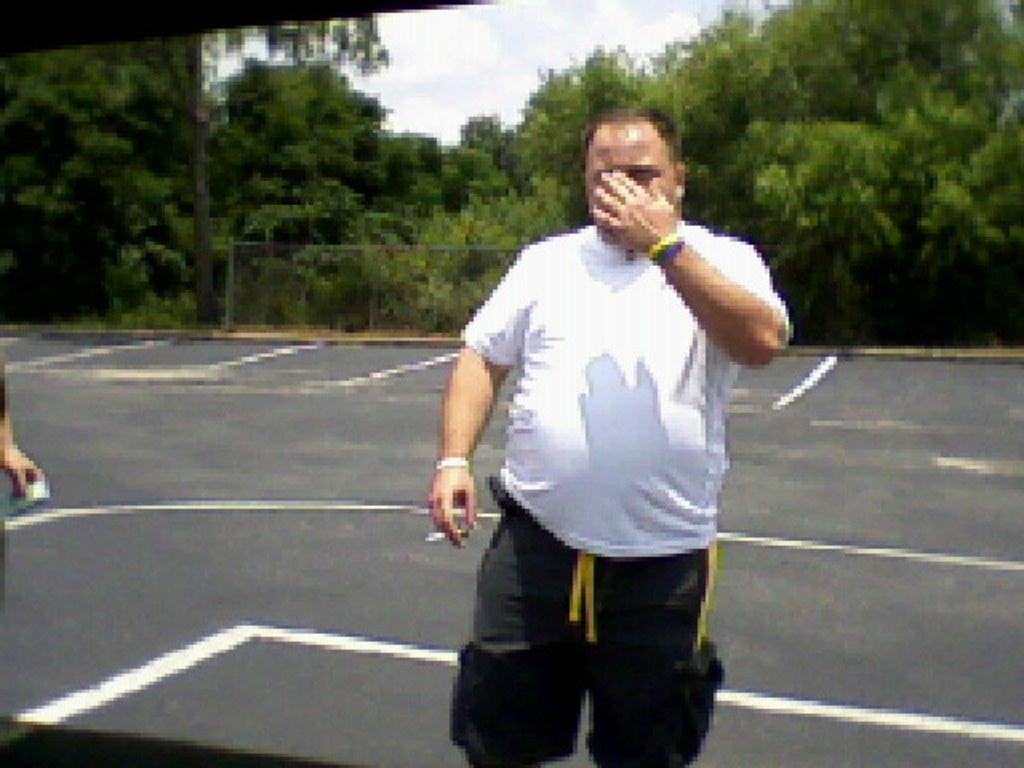Could you give a brief overview of what you see in this image? In this image I can see a road and on it I can see number of white lines and two persons. I can also see one man is holding a cigarette, I can see he is wearing white colour t shirt and pant. In the background I can see number of trees, the sky and I can see this image is little bit blurry. 